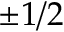<formula> <loc_0><loc_0><loc_500><loc_500>\pm 1 / 2</formula> 